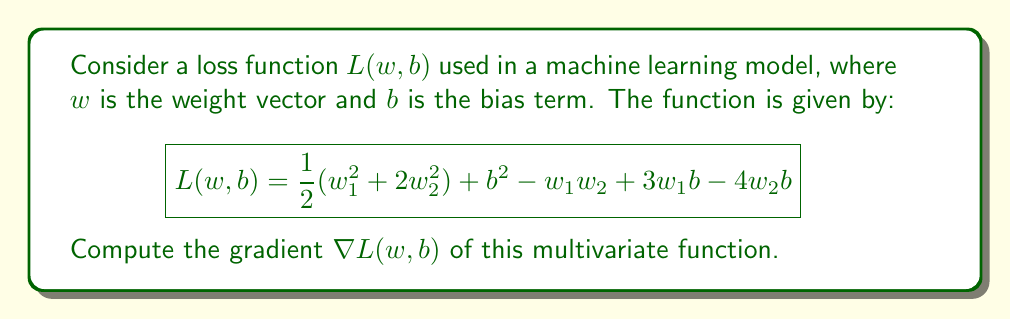Could you help me with this problem? To compute the gradient of the multivariate function $L(w, b)$, we need to calculate the partial derivatives with respect to each variable: $w_1$, $w_2$, and $b$.

Step 1: Calculate $\frac{\partial L}{\partial w_1}$
$$\frac{\partial L}{\partial w_1} = w_1 - w_2 + 3b$$

Step 2: Calculate $\frac{\partial L}{\partial w_2}$
$$\frac{\partial L}{\partial w_2} = 4w_2 - w_1 - 4b$$

Step 3: Calculate $\frac{\partial L}{\partial b}$
$$\frac{\partial L}{\partial b} = 2b + 3w_1 - 4w_2$$

Step 4: Combine the partial derivatives to form the gradient vector
The gradient $\nabla L(w, b)$ is a vector containing all partial derivatives:

$$\nabla L(w, b) = \begin{bmatrix}
\frac{\partial L}{\partial w_1} \\
\frac{\partial L}{\partial w_2} \\
\frac{\partial L}{\partial b}
\end{bmatrix} = \begin{bmatrix}
w_1 - w_2 + 3b \\
4w_2 - w_1 - 4b \\
2b + 3w_1 - 4w_2
\end{bmatrix}$$
Answer: $$\nabla L(w, b) = \begin{bmatrix}
w_1 - w_2 + 3b \\
4w_2 - w_1 - 4b \\
2b + 3w_1 - 4w_2
\end{bmatrix}$$ 